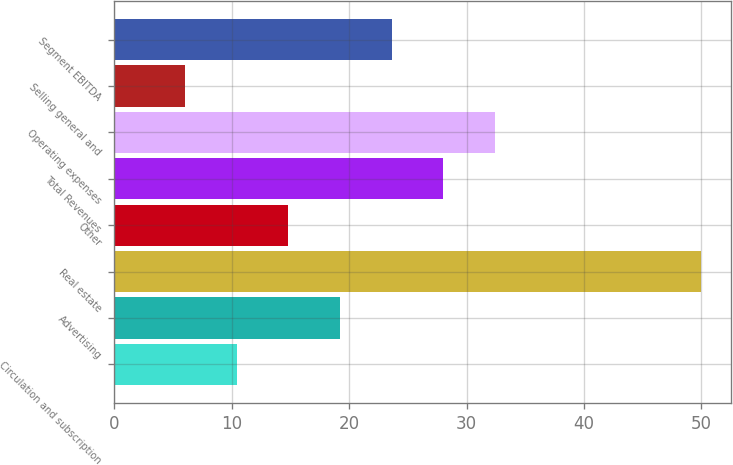<chart> <loc_0><loc_0><loc_500><loc_500><bar_chart><fcel>Circulation and subscription<fcel>Advertising<fcel>Real estate<fcel>Other<fcel>Total Revenues<fcel>Operating expenses<fcel>Selling general and<fcel>Segment EBITDA<nl><fcel>10.4<fcel>19.2<fcel>50<fcel>14.8<fcel>28<fcel>32.4<fcel>6<fcel>23.6<nl></chart> 